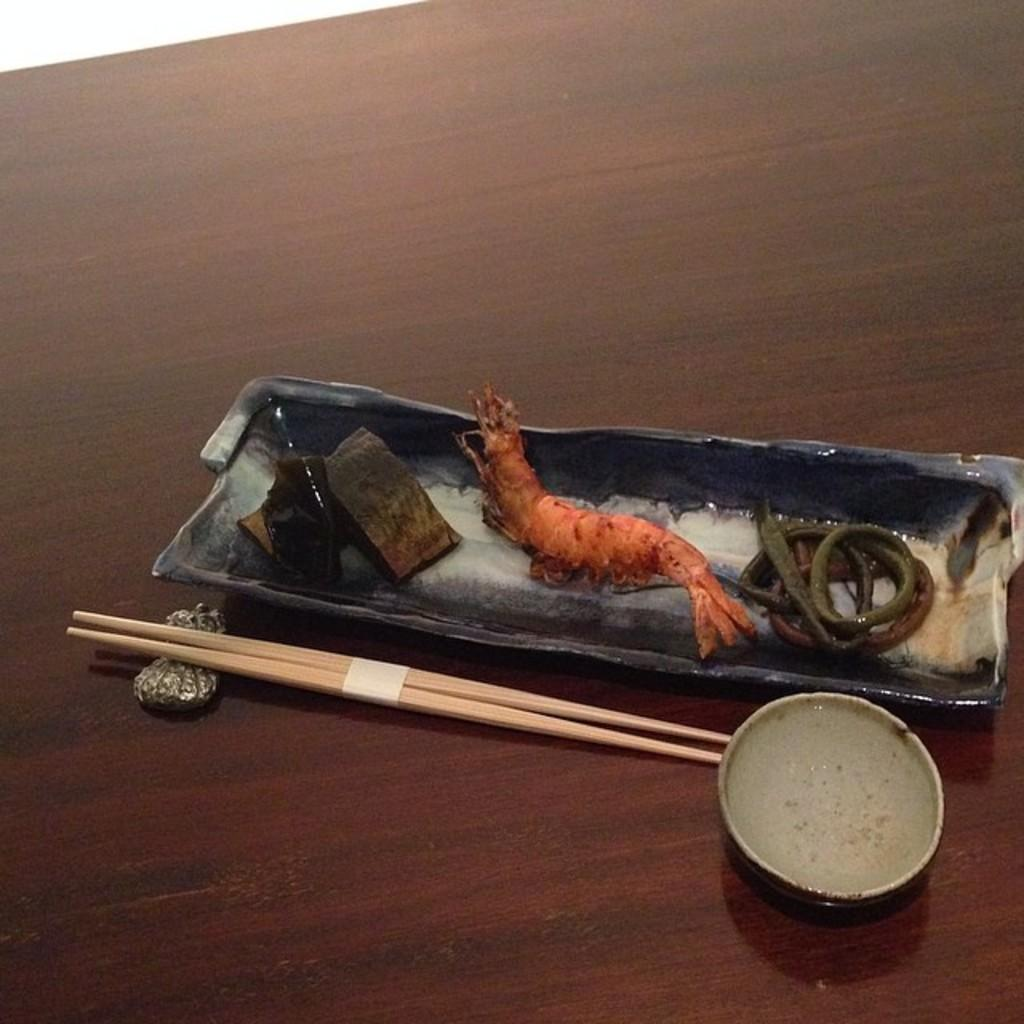What utensils are present in the image? There are chopsticks in the image. What type of food can be seen in the image? There are prawns in the image. Where are the prawns located? The prawns are in a bowl. On what surface is the bowl placed? The bowl is placed on a table. How does the ant smash the prawns in the image? There is no ant present in the image, and therefore no such action can be observed. 